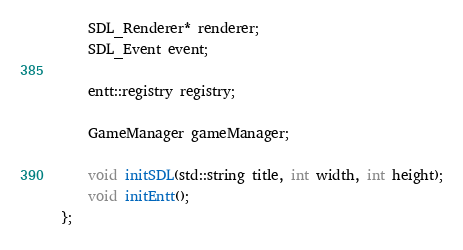Convert code to text. <code><loc_0><loc_0><loc_500><loc_500><_C_>	SDL_Renderer* renderer;
	SDL_Event event;
	
	entt::registry registry;

	GameManager gameManager;

	void initSDL(std::string title, int width, int height);
	void initEntt();
};</code> 